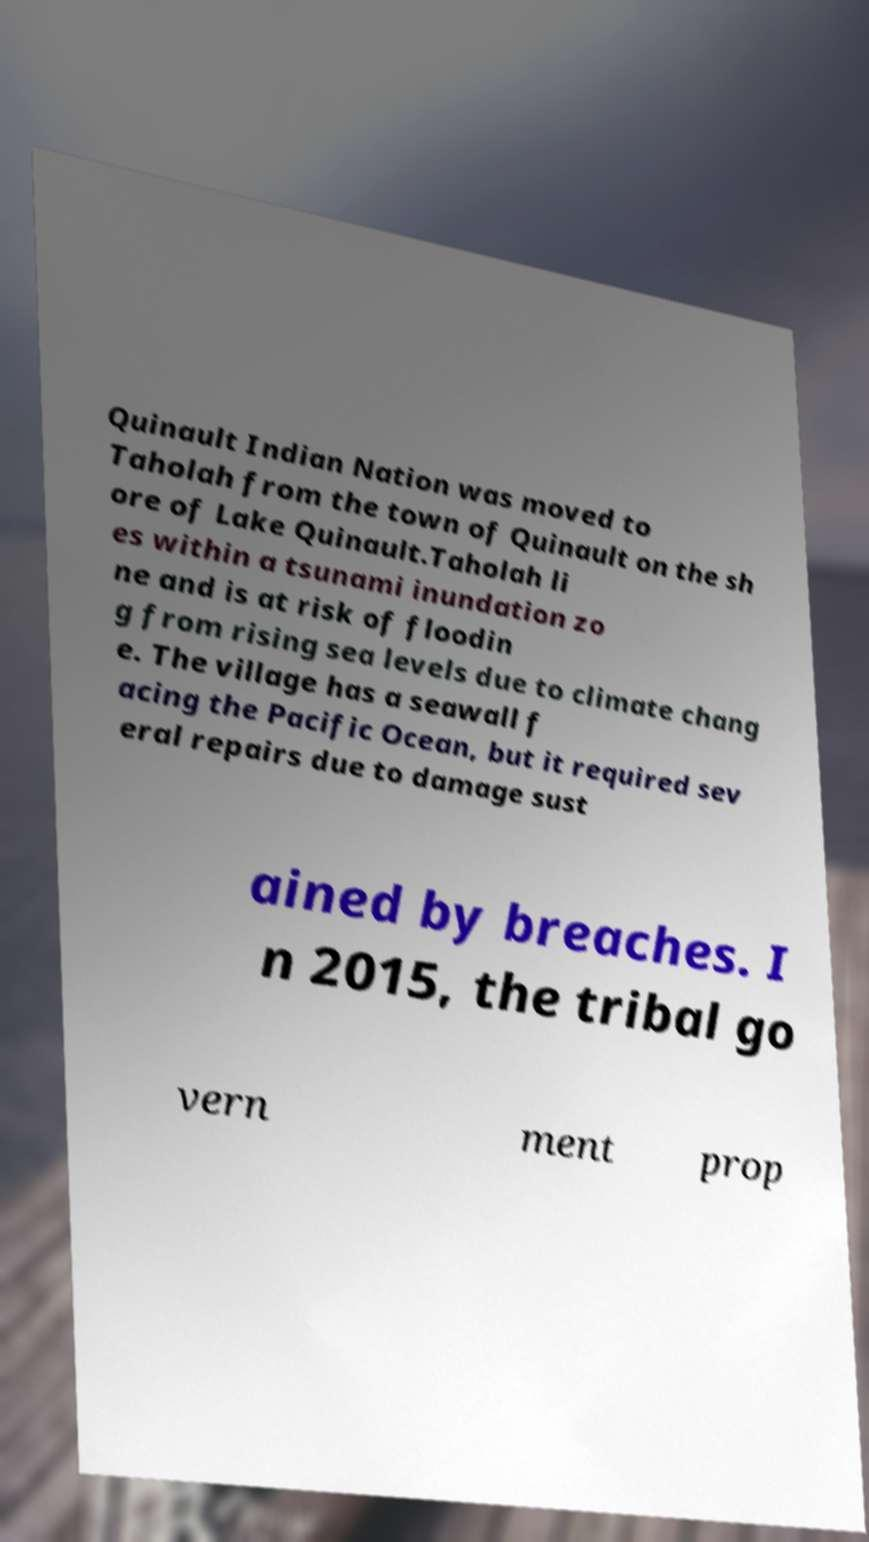Can you accurately transcribe the text from the provided image for me? Quinault Indian Nation was moved to Taholah from the town of Quinault on the sh ore of Lake Quinault.Taholah li es within a tsunami inundation zo ne and is at risk of floodin g from rising sea levels due to climate chang e. The village has a seawall f acing the Pacific Ocean, but it required sev eral repairs due to damage sust ained by breaches. I n 2015, the tribal go vern ment prop 